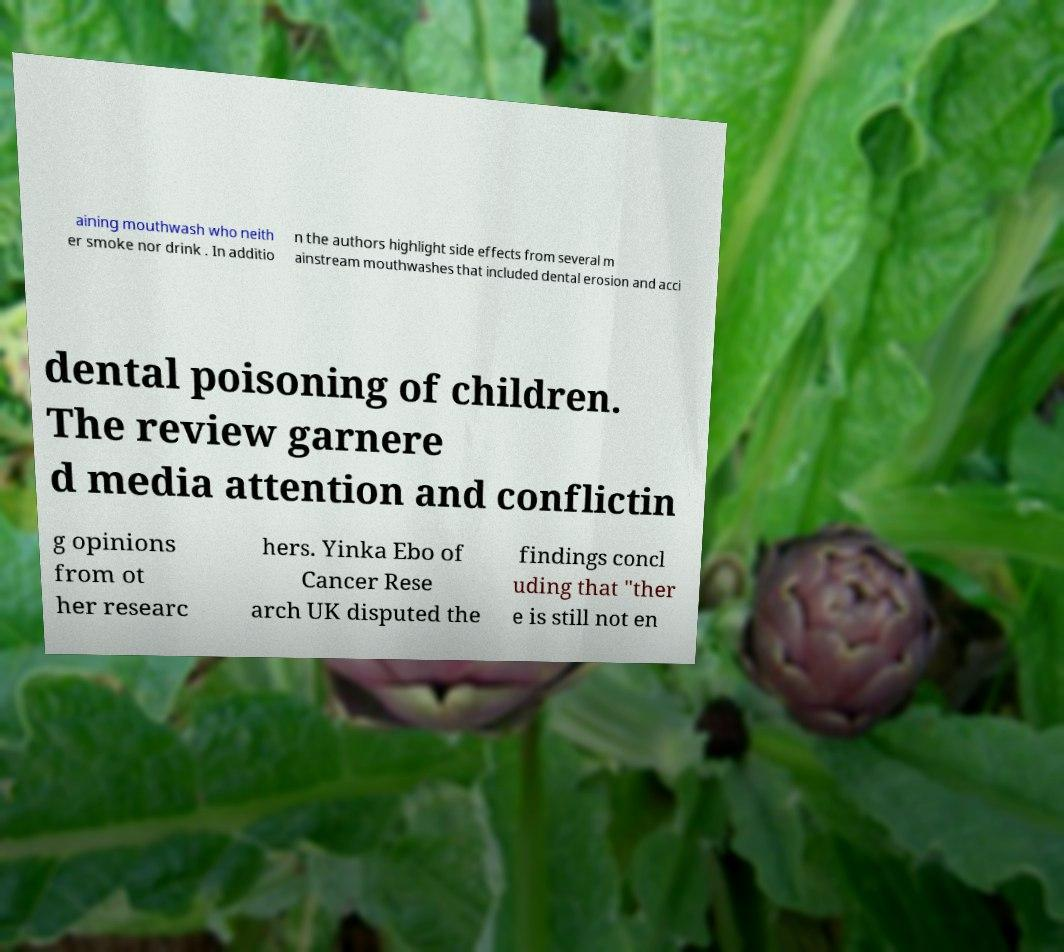For documentation purposes, I need the text within this image transcribed. Could you provide that? aining mouthwash who neith er smoke nor drink . In additio n the authors highlight side effects from several m ainstream mouthwashes that included dental erosion and acci dental poisoning of children. The review garnere d media attention and conflictin g opinions from ot her researc hers. Yinka Ebo of Cancer Rese arch UK disputed the findings concl uding that "ther e is still not en 